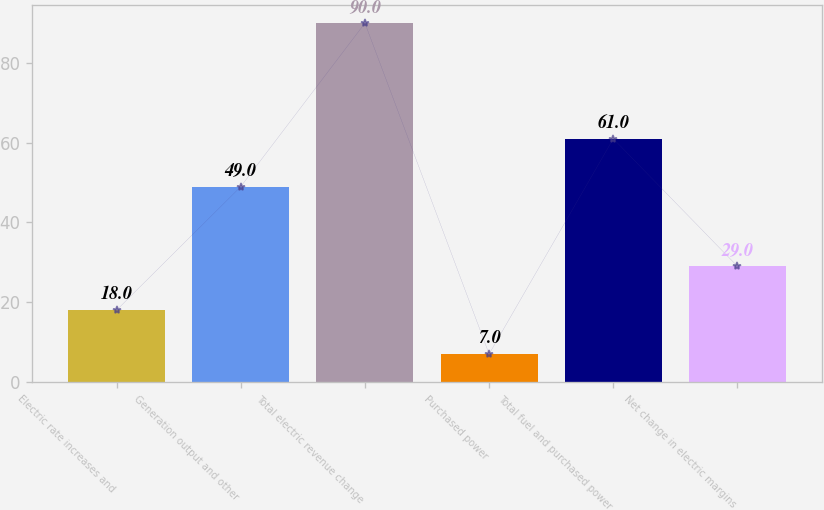<chart> <loc_0><loc_0><loc_500><loc_500><bar_chart><fcel>Electric rate increases and<fcel>Generation output and other<fcel>Total electric revenue change<fcel>Purchased power<fcel>Total fuel and purchased power<fcel>Net change in electric margins<nl><fcel>18<fcel>49<fcel>90<fcel>7<fcel>61<fcel>29<nl></chart> 